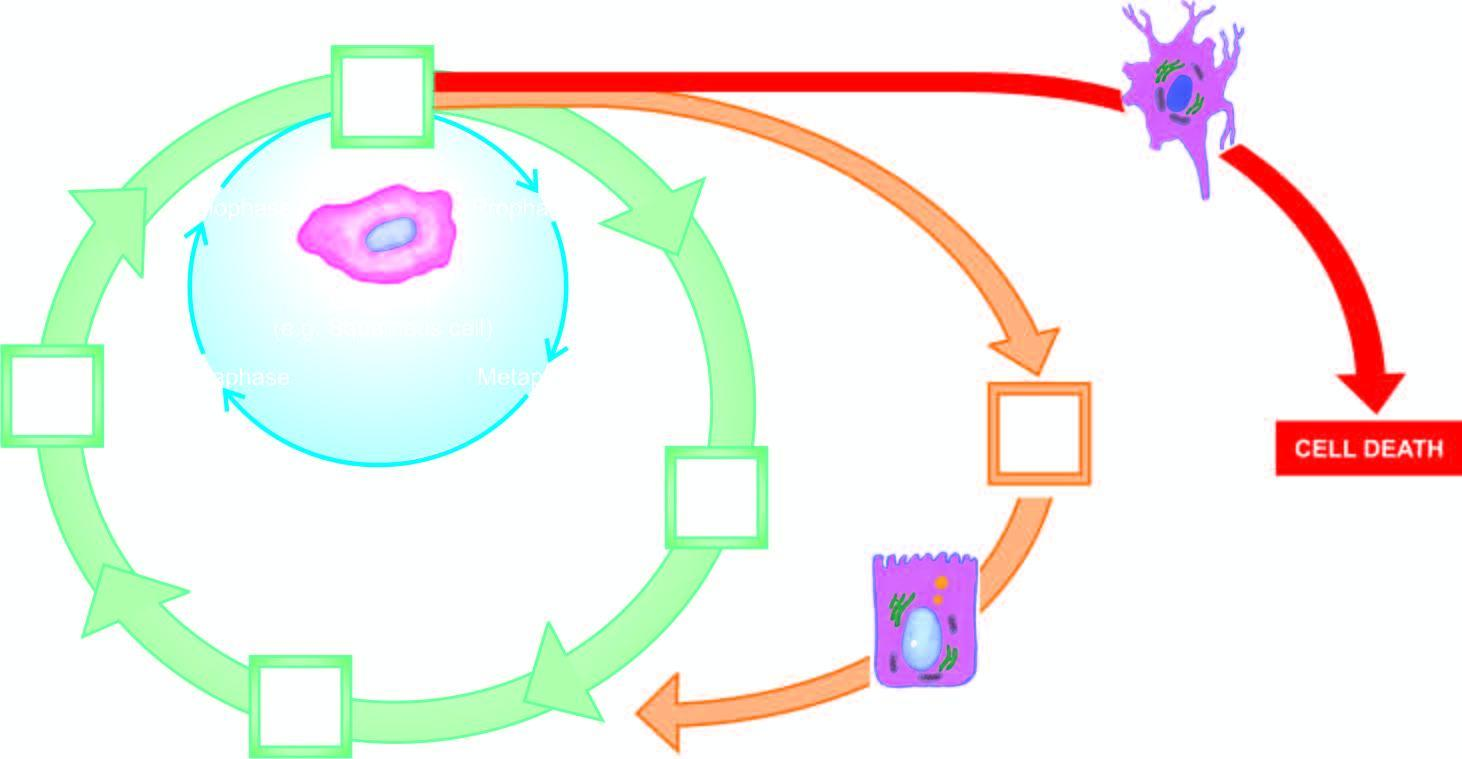does the particle represent cell cycle for stable cells?
Answer the question using a single word or phrase. No 